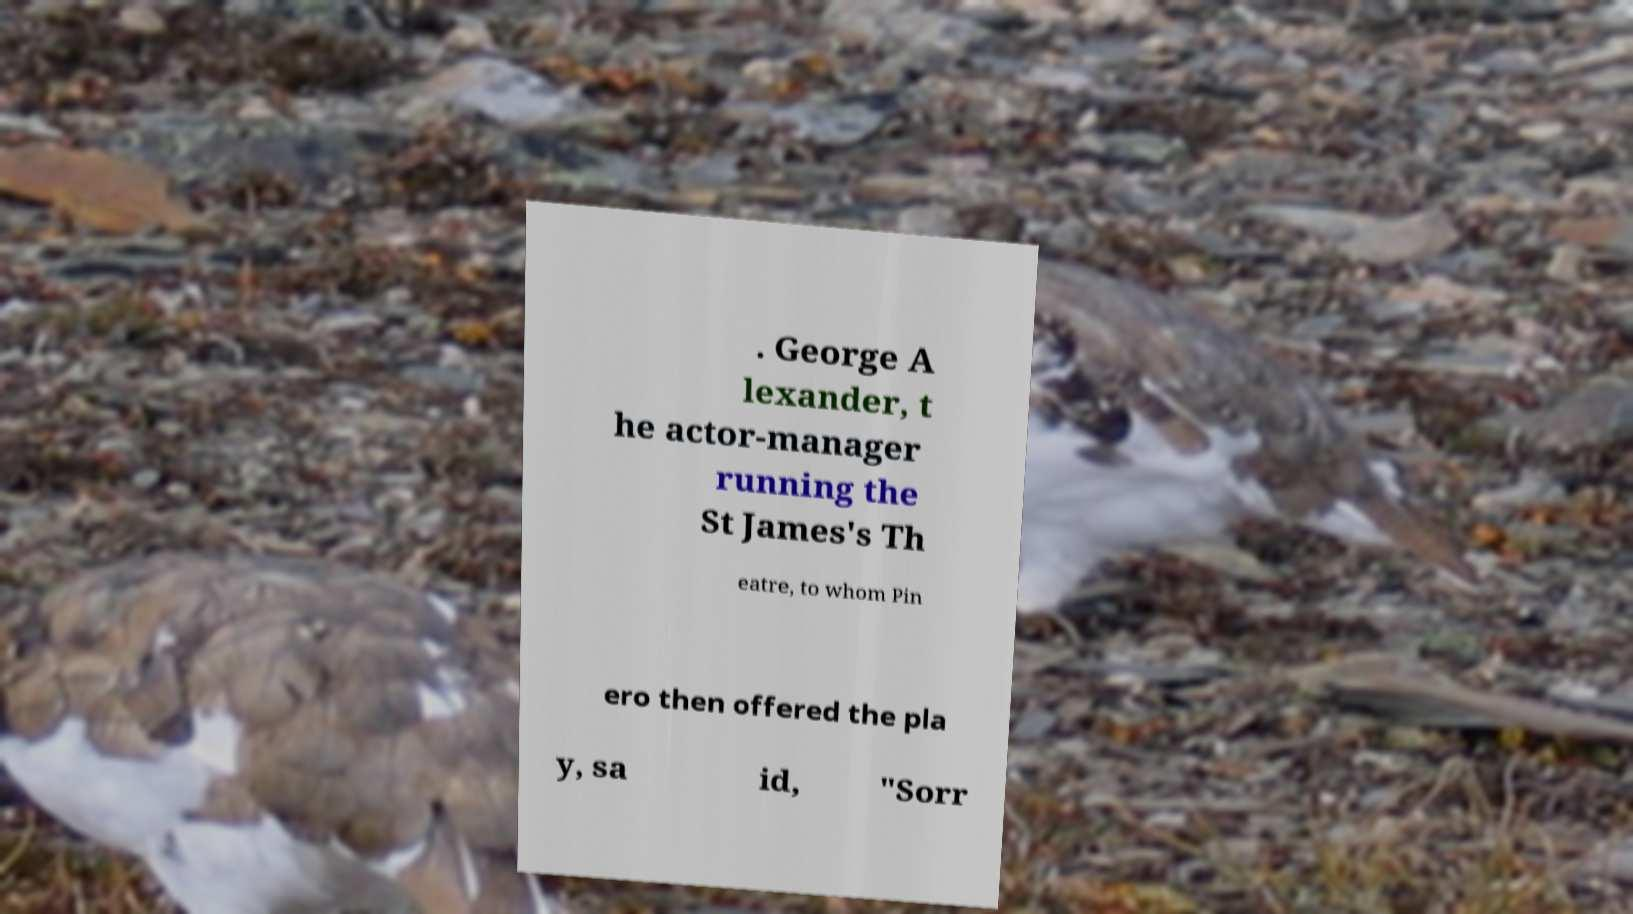Please identify and transcribe the text found in this image. . George A lexander, t he actor-manager running the St James's Th eatre, to whom Pin ero then offered the pla y, sa id, "Sorr 